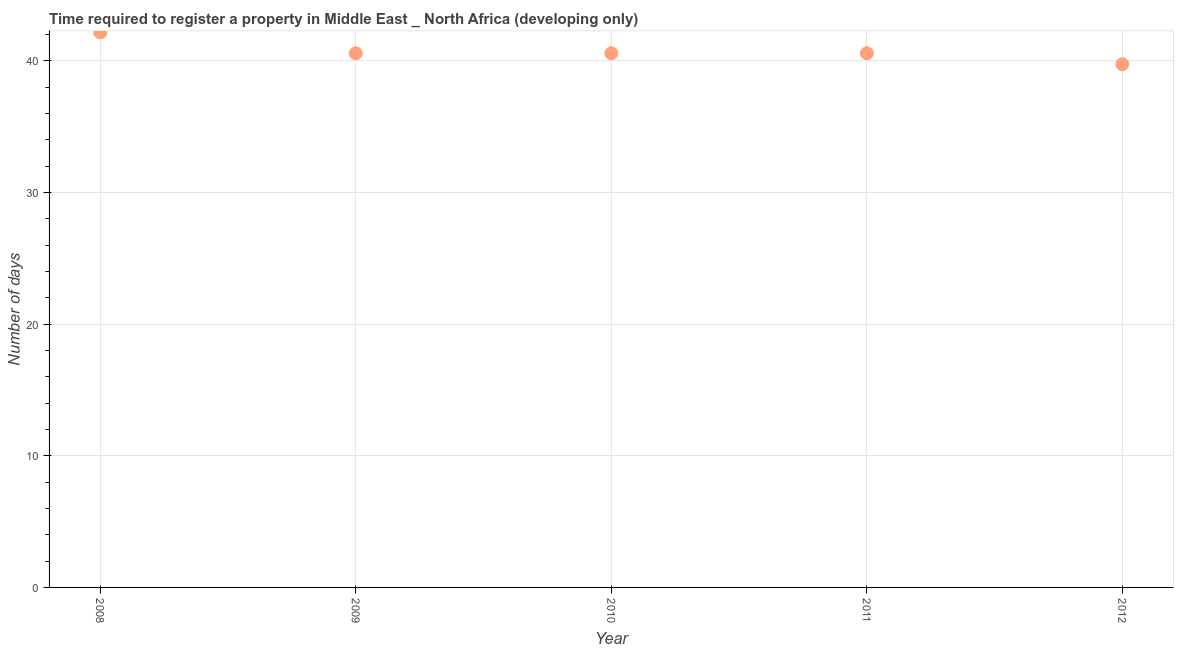What is the number of days required to register property in 2009?
Your response must be concise. 40.58. Across all years, what is the maximum number of days required to register property?
Give a very brief answer. 42.17. Across all years, what is the minimum number of days required to register property?
Ensure brevity in your answer.  39.75. In which year was the number of days required to register property minimum?
Keep it short and to the point. 2012. What is the sum of the number of days required to register property?
Ensure brevity in your answer.  203.67. What is the difference between the number of days required to register property in 2008 and 2010?
Make the answer very short. 1.58. What is the average number of days required to register property per year?
Your response must be concise. 40.73. What is the median number of days required to register property?
Offer a very short reply. 40.58. Do a majority of the years between 2009 and 2010 (inclusive) have number of days required to register property greater than 20 days?
Offer a terse response. Yes. Is the difference between the number of days required to register property in 2008 and 2011 greater than the difference between any two years?
Your answer should be very brief. No. What is the difference between the highest and the second highest number of days required to register property?
Provide a short and direct response. 1.58. What is the difference between the highest and the lowest number of days required to register property?
Your answer should be compact. 2.42. In how many years, is the number of days required to register property greater than the average number of days required to register property taken over all years?
Make the answer very short. 1. What is the difference between two consecutive major ticks on the Y-axis?
Ensure brevity in your answer.  10. What is the title of the graph?
Offer a very short reply. Time required to register a property in Middle East _ North Africa (developing only). What is the label or title of the X-axis?
Provide a short and direct response. Year. What is the label or title of the Y-axis?
Make the answer very short. Number of days. What is the Number of days in 2008?
Make the answer very short. 42.17. What is the Number of days in 2009?
Make the answer very short. 40.58. What is the Number of days in 2010?
Make the answer very short. 40.58. What is the Number of days in 2011?
Your response must be concise. 40.58. What is the Number of days in 2012?
Provide a succinct answer. 39.75. What is the difference between the Number of days in 2008 and 2009?
Make the answer very short. 1.58. What is the difference between the Number of days in 2008 and 2010?
Your answer should be very brief. 1.58. What is the difference between the Number of days in 2008 and 2011?
Your response must be concise. 1.58. What is the difference between the Number of days in 2008 and 2012?
Make the answer very short. 2.42. What is the difference between the Number of days in 2009 and 2010?
Offer a terse response. 0. What is the difference between the Number of days in 2009 and 2012?
Provide a short and direct response. 0.83. What is the difference between the Number of days in 2010 and 2012?
Ensure brevity in your answer.  0.83. What is the difference between the Number of days in 2011 and 2012?
Provide a succinct answer. 0.83. What is the ratio of the Number of days in 2008 to that in 2009?
Your response must be concise. 1.04. What is the ratio of the Number of days in 2008 to that in 2010?
Your answer should be very brief. 1.04. What is the ratio of the Number of days in 2008 to that in 2011?
Offer a terse response. 1.04. What is the ratio of the Number of days in 2008 to that in 2012?
Keep it short and to the point. 1.06. What is the ratio of the Number of days in 2009 to that in 2010?
Offer a very short reply. 1. What is the ratio of the Number of days in 2009 to that in 2011?
Provide a succinct answer. 1. What is the ratio of the Number of days in 2009 to that in 2012?
Offer a very short reply. 1.02. What is the ratio of the Number of days in 2010 to that in 2012?
Your answer should be compact. 1.02. What is the ratio of the Number of days in 2011 to that in 2012?
Provide a succinct answer. 1.02. 